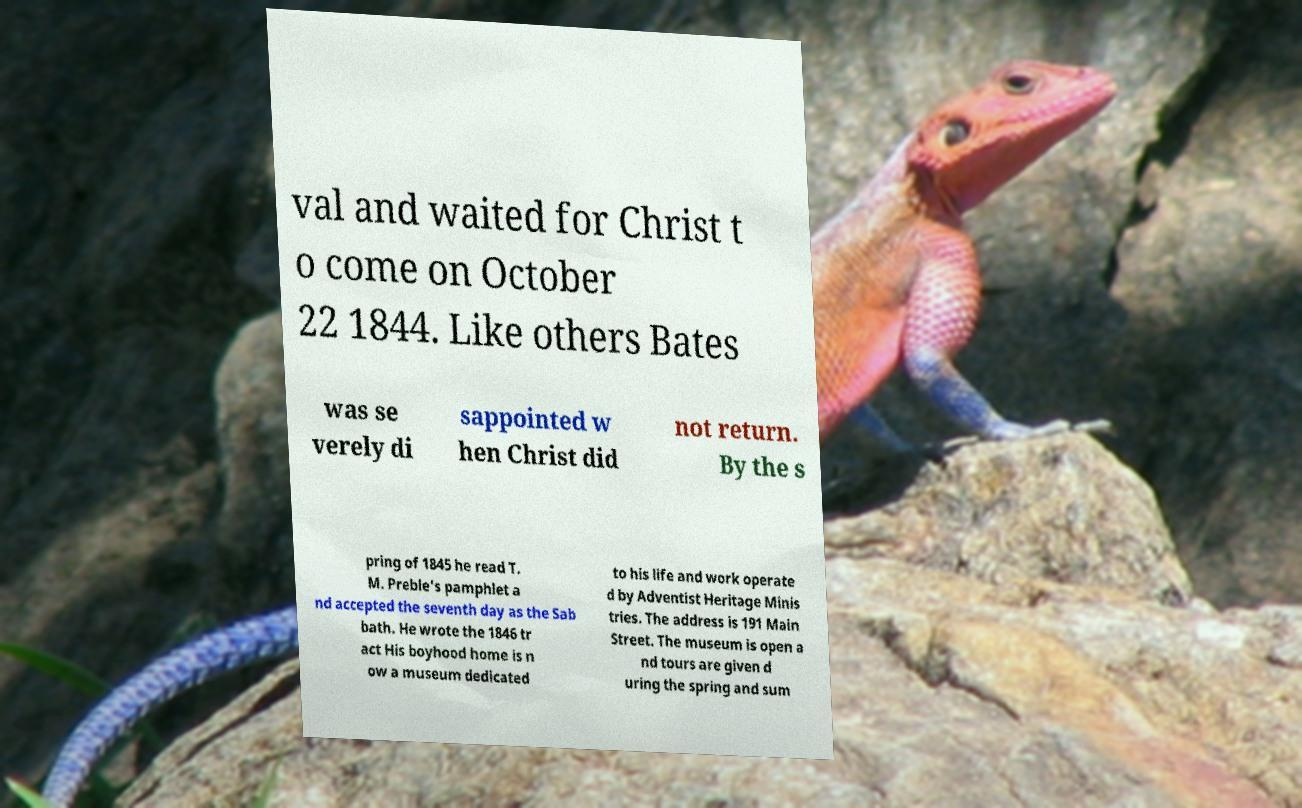Can you accurately transcribe the text from the provided image for me? val and waited for Christ t o come on October 22 1844. Like others Bates was se verely di sappointed w hen Christ did not return. By the s pring of 1845 he read T. M. Preble's pamphlet a nd accepted the seventh day as the Sab bath. He wrote the 1846 tr act His boyhood home is n ow a museum dedicated to his life and work operate d by Adventist Heritage Minis tries. The address is 191 Main Street. The museum is open a nd tours are given d uring the spring and sum 